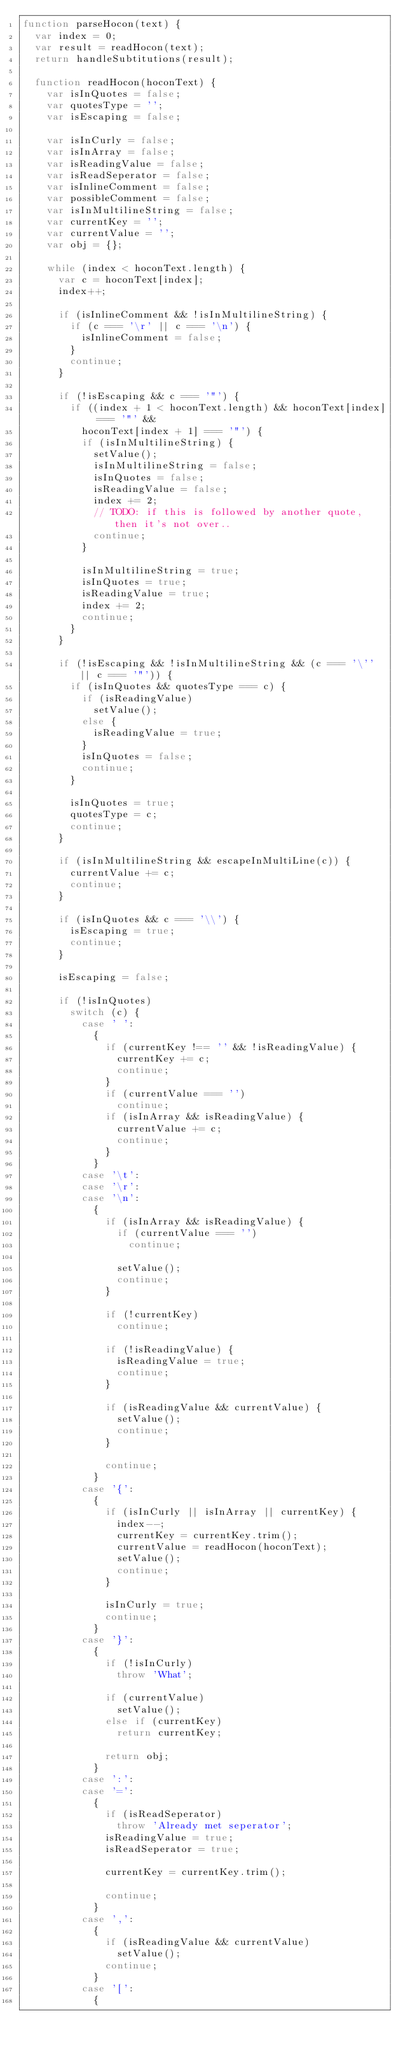Convert code to text. <code><loc_0><loc_0><loc_500><loc_500><_JavaScript_>function parseHocon(text) {
  var index = 0;
  var result = readHocon(text);
  return handleSubtitutions(result);

  function readHocon(hoconText) {
    var isInQuotes = false;
    var quotesType = '';
    var isEscaping = false;

    var isInCurly = false;
    var isInArray = false;
    var isReadingValue = false;
    var isReadSeperator = false;
    var isInlineComment = false;
    var possibleComment = false;
    var isInMultilineString = false;
    var currentKey = '';
    var currentValue = '';
    var obj = {};

    while (index < hoconText.length) {
      var c = hoconText[index];
      index++;

      if (isInlineComment && !isInMultilineString) {
        if (c === '\r' || c === '\n') {
          isInlineComment = false;
        }
        continue;
      }

      if (!isEscaping && c === '"') {
        if ((index + 1 < hoconText.length) && hoconText[index] === '"' &&
          hoconText[index + 1] === '"') {
          if (isInMultilineString) {
            setValue();
            isInMultilineString = false;
            isInQuotes = false;
            isReadingValue = false;
            index += 2;
            // TODO: if this is followed by another quote, then it's not over..
            continue;
          }

          isInMultilineString = true;
          isInQuotes = true;
          isReadingValue = true;
          index += 2;
          continue;
        }
      }

      if (!isEscaping && !isInMultilineString && (c === '\'' || c === '"')) {
        if (isInQuotes && quotesType === c) {
          if (isReadingValue)
            setValue();
          else {
            isReadingValue = true;
          }
          isInQuotes = false;
          continue;
        }

        isInQuotes = true;
        quotesType = c;
        continue;
      }

      if (isInMultilineString && escapeInMultiLine(c)) {
        currentValue += c;
        continue;
      }

      if (isInQuotes && c === '\\') {
        isEscaping = true;
        continue;
      }

      isEscaping = false;

      if (!isInQuotes)
        switch (c) {
          case ' ':
            {
              if (currentKey !== '' && !isReadingValue) {
                currentKey += c;
                continue;
              }
              if (currentValue === '')
                continue;
              if (isInArray && isReadingValue) {
                currentValue += c;
                continue;
              }
            }
          case '\t':
          case '\r':
          case '\n':
            {
              if (isInArray && isReadingValue) {
                if (currentValue === '')
                  continue;

                setValue();
                continue;
              }

              if (!currentKey)
                continue;

              if (!isReadingValue) {
                isReadingValue = true;
                continue;
              }

              if (isReadingValue && currentValue) {
                setValue();
                continue;
              }

              continue;
            }
          case '{':
            {
              if (isInCurly || isInArray || currentKey) {
                index--;
                currentKey = currentKey.trim();
                currentValue = readHocon(hoconText);
                setValue();
                continue;
              }

              isInCurly = true;
              continue;
            }
          case '}':
            {
              if (!isInCurly)
                throw 'What';

              if (currentValue)
                setValue();
              else if (currentKey)
                return currentKey;

              return obj;
            }
          case ':':
          case '=':
            {
              if (isReadSeperator)
                throw 'Already met seperator';
              isReadingValue = true;
              isReadSeperator = true;

              currentKey = currentKey.trim();

              continue;
            }
          case ',':
            {
              if (isReadingValue && currentValue)
                setValue();
              continue;
            }
          case '[':
            {</code> 